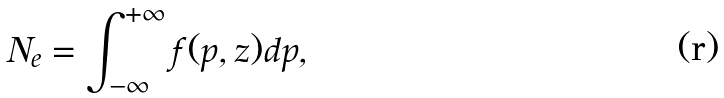Convert formula to latex. <formula><loc_0><loc_0><loc_500><loc_500>N _ { e } = \int _ { - \infty } ^ { + \infty } f ( p , z ) d p ,</formula> 